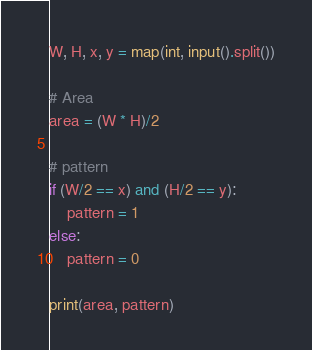Convert code to text. <code><loc_0><loc_0><loc_500><loc_500><_Python_>W, H, x, y = map(int, input().split())

# Area
area = (W * H)/2

# pattern
if (W/2 == x) and (H/2 == y):
    pattern = 1
else:
    pattern = 0

print(area, pattern)
</code> 